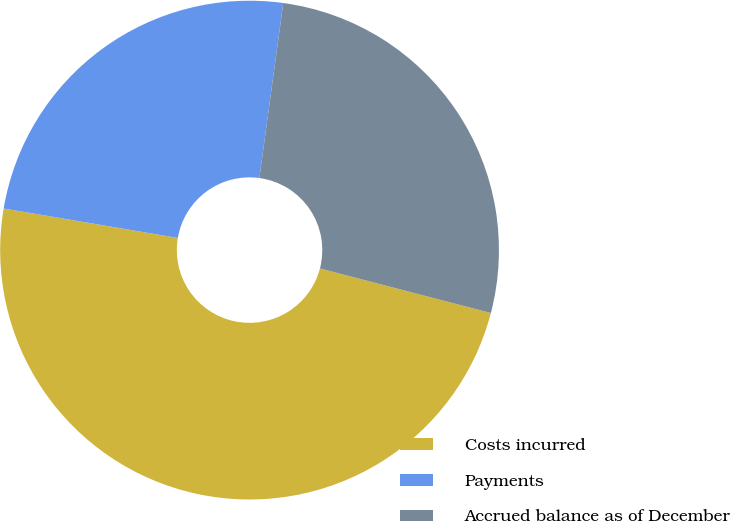Convert chart to OTSL. <chart><loc_0><loc_0><loc_500><loc_500><pie_chart><fcel>Costs incurred<fcel>Payments<fcel>Accrued balance as of December<nl><fcel>48.61%<fcel>24.49%<fcel>26.9%<nl></chart> 